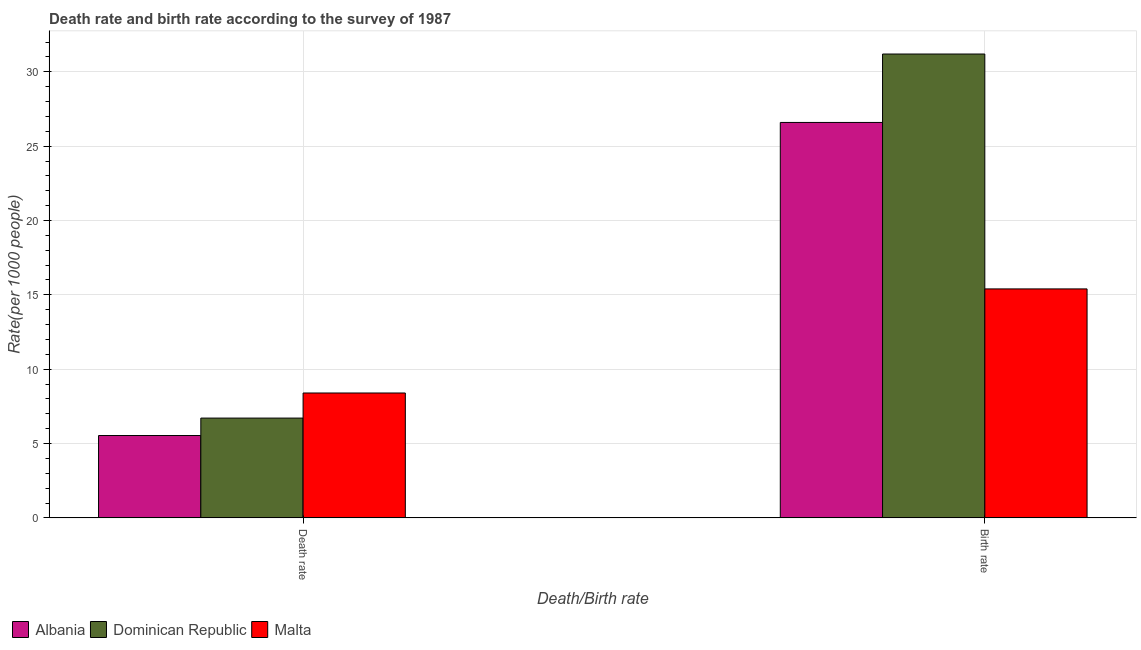How many different coloured bars are there?
Keep it short and to the point. 3. How many groups of bars are there?
Offer a very short reply. 2. Are the number of bars per tick equal to the number of legend labels?
Offer a very short reply. Yes. What is the label of the 2nd group of bars from the left?
Offer a very short reply. Birth rate. What is the birth rate in Malta?
Your answer should be compact. 15.4. Across all countries, what is the maximum birth rate?
Your answer should be very brief. 31.2. Across all countries, what is the minimum birth rate?
Provide a succinct answer. 15.4. In which country was the death rate maximum?
Your response must be concise. Malta. In which country was the death rate minimum?
Provide a succinct answer. Albania. What is the total birth rate in the graph?
Ensure brevity in your answer.  73.19. What is the difference between the birth rate in Albania and that in Dominican Republic?
Offer a terse response. -4.6. What is the difference between the birth rate in Albania and the death rate in Malta?
Give a very brief answer. 18.2. What is the average death rate per country?
Offer a terse response. 6.88. What is the difference between the death rate and birth rate in Dominican Republic?
Offer a very short reply. -24.48. In how many countries, is the birth rate greater than 6 ?
Offer a very short reply. 3. What is the ratio of the birth rate in Dominican Republic to that in Malta?
Your answer should be compact. 2.03. What does the 1st bar from the left in Birth rate represents?
Offer a terse response. Albania. What does the 3rd bar from the right in Death rate represents?
Your answer should be very brief. Albania. How many bars are there?
Offer a terse response. 6. Are all the bars in the graph horizontal?
Keep it short and to the point. No. How many countries are there in the graph?
Provide a short and direct response. 3. What is the difference between two consecutive major ticks on the Y-axis?
Your answer should be very brief. 5. Are the values on the major ticks of Y-axis written in scientific E-notation?
Keep it short and to the point. No. Does the graph contain any zero values?
Ensure brevity in your answer.  No. Does the graph contain grids?
Your response must be concise. Yes. Where does the legend appear in the graph?
Offer a very short reply. Bottom left. How many legend labels are there?
Offer a very short reply. 3. What is the title of the graph?
Your answer should be very brief. Death rate and birth rate according to the survey of 1987. What is the label or title of the X-axis?
Provide a succinct answer. Death/Birth rate. What is the label or title of the Y-axis?
Keep it short and to the point. Rate(per 1000 people). What is the Rate(per 1000 people) of Albania in Death rate?
Offer a terse response. 5.54. What is the Rate(per 1000 people) of Dominican Republic in Death rate?
Provide a succinct answer. 6.71. What is the Rate(per 1000 people) of Albania in Birth rate?
Your answer should be compact. 26.59. What is the Rate(per 1000 people) of Dominican Republic in Birth rate?
Ensure brevity in your answer.  31.2. What is the Rate(per 1000 people) in Malta in Birth rate?
Offer a terse response. 15.4. Across all Death/Birth rate, what is the maximum Rate(per 1000 people) of Albania?
Make the answer very short. 26.59. Across all Death/Birth rate, what is the maximum Rate(per 1000 people) of Dominican Republic?
Offer a very short reply. 31.2. Across all Death/Birth rate, what is the maximum Rate(per 1000 people) in Malta?
Ensure brevity in your answer.  15.4. Across all Death/Birth rate, what is the minimum Rate(per 1000 people) of Albania?
Offer a terse response. 5.54. Across all Death/Birth rate, what is the minimum Rate(per 1000 people) of Dominican Republic?
Keep it short and to the point. 6.71. What is the total Rate(per 1000 people) of Albania in the graph?
Offer a very short reply. 32.13. What is the total Rate(per 1000 people) of Dominican Republic in the graph?
Ensure brevity in your answer.  37.91. What is the total Rate(per 1000 people) of Malta in the graph?
Offer a very short reply. 23.8. What is the difference between the Rate(per 1000 people) in Albania in Death rate and that in Birth rate?
Make the answer very short. -21.05. What is the difference between the Rate(per 1000 people) of Dominican Republic in Death rate and that in Birth rate?
Provide a succinct answer. -24.48. What is the difference between the Rate(per 1000 people) of Malta in Death rate and that in Birth rate?
Ensure brevity in your answer.  -7. What is the difference between the Rate(per 1000 people) in Albania in Death rate and the Rate(per 1000 people) in Dominican Republic in Birth rate?
Your response must be concise. -25.66. What is the difference between the Rate(per 1000 people) of Albania in Death rate and the Rate(per 1000 people) of Malta in Birth rate?
Your answer should be compact. -9.86. What is the difference between the Rate(per 1000 people) in Dominican Republic in Death rate and the Rate(per 1000 people) in Malta in Birth rate?
Make the answer very short. -8.69. What is the average Rate(per 1000 people) in Albania per Death/Birth rate?
Offer a terse response. 16.07. What is the average Rate(per 1000 people) in Dominican Republic per Death/Birth rate?
Make the answer very short. 18.95. What is the average Rate(per 1000 people) in Malta per Death/Birth rate?
Your answer should be compact. 11.9. What is the difference between the Rate(per 1000 people) of Albania and Rate(per 1000 people) of Dominican Republic in Death rate?
Provide a short and direct response. -1.17. What is the difference between the Rate(per 1000 people) of Albania and Rate(per 1000 people) of Malta in Death rate?
Your answer should be compact. -2.86. What is the difference between the Rate(per 1000 people) of Dominican Republic and Rate(per 1000 people) of Malta in Death rate?
Keep it short and to the point. -1.69. What is the difference between the Rate(per 1000 people) in Albania and Rate(per 1000 people) in Dominican Republic in Birth rate?
Offer a terse response. -4.6. What is the difference between the Rate(per 1000 people) of Albania and Rate(per 1000 people) of Malta in Birth rate?
Your answer should be very brief. 11.2. What is the difference between the Rate(per 1000 people) in Dominican Republic and Rate(per 1000 people) in Malta in Birth rate?
Your answer should be very brief. 15.8. What is the ratio of the Rate(per 1000 people) in Albania in Death rate to that in Birth rate?
Ensure brevity in your answer.  0.21. What is the ratio of the Rate(per 1000 people) in Dominican Republic in Death rate to that in Birth rate?
Your response must be concise. 0.22. What is the ratio of the Rate(per 1000 people) of Malta in Death rate to that in Birth rate?
Make the answer very short. 0.55. What is the difference between the highest and the second highest Rate(per 1000 people) of Albania?
Your response must be concise. 21.05. What is the difference between the highest and the second highest Rate(per 1000 people) of Dominican Republic?
Ensure brevity in your answer.  24.48. What is the difference between the highest and the second highest Rate(per 1000 people) in Malta?
Ensure brevity in your answer.  7. What is the difference between the highest and the lowest Rate(per 1000 people) in Albania?
Your answer should be compact. 21.05. What is the difference between the highest and the lowest Rate(per 1000 people) of Dominican Republic?
Offer a terse response. 24.48. What is the difference between the highest and the lowest Rate(per 1000 people) of Malta?
Provide a short and direct response. 7. 